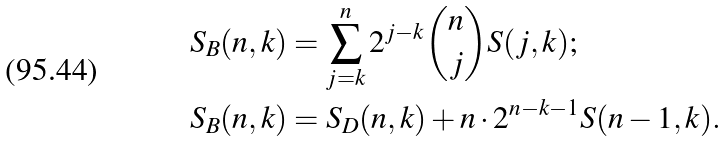<formula> <loc_0><loc_0><loc_500><loc_500>S _ { B } ( n , k ) & = \sum _ { j = k } ^ { n } 2 ^ { j - k } \binom { n } { j } S ( j , k ) ; \\ S _ { B } ( n , k ) & = S _ { D } ( n , k ) + n \cdot 2 ^ { n - k - 1 } S ( n - 1 , k ) .</formula> 